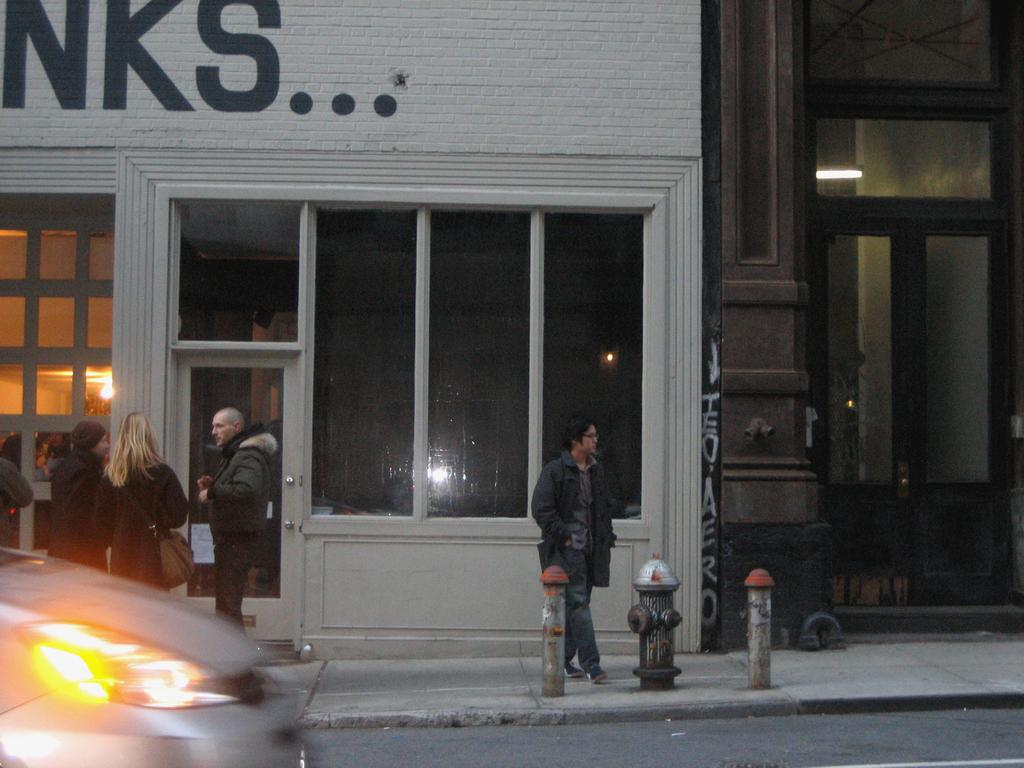What is happening in the foreground of the image? There is a car moving in the foreground of the image. Where is the car located? The car is on the road. What can be seen in the image besides the car? There are poles, people, and buildings in the image. What is visible in the background of the image? There are buildings in the background of the image. Can you see any worms crawling on the car in the image? No, there are no worms visible on the car in the image. What type of muscle is being exercised by the people in the image? There are no specific muscles being exercised by the people in the image; they are simply present. 